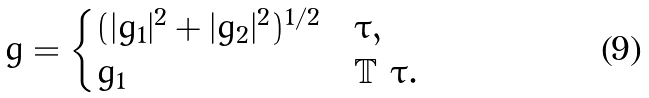<formula> <loc_0><loc_0><loc_500><loc_500>g = \begin{cases} ( | g _ { 1 } | ^ { 2 } + | g _ { 2 } | ^ { 2 } ) ^ { 1 / 2 } & \tau , \\ g _ { 1 } & \mathbb { T } \ \tau . \end{cases}</formula> 